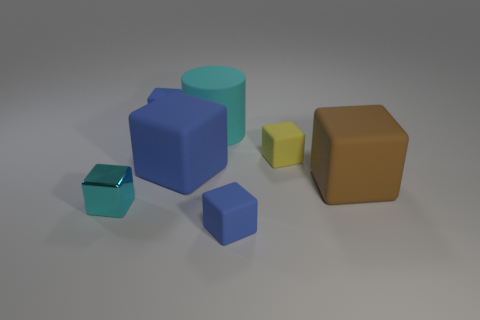Subtract all blue cubes. How many were subtracted if there are1blue cubes left? 2 Subtract all cyan cubes. How many cubes are left? 5 Subtract all yellow matte blocks. How many blocks are left? 5 Subtract all purple blocks. How many green cylinders are left? 0 Subtract all tiny blue blocks. Subtract all large brown rubber objects. How many objects are left? 4 Add 1 small matte blocks. How many small matte blocks are left? 4 Add 6 blue balls. How many blue balls exist? 6 Add 1 green spheres. How many objects exist? 8 Subtract 0 red cylinders. How many objects are left? 7 Subtract all blocks. How many objects are left? 1 